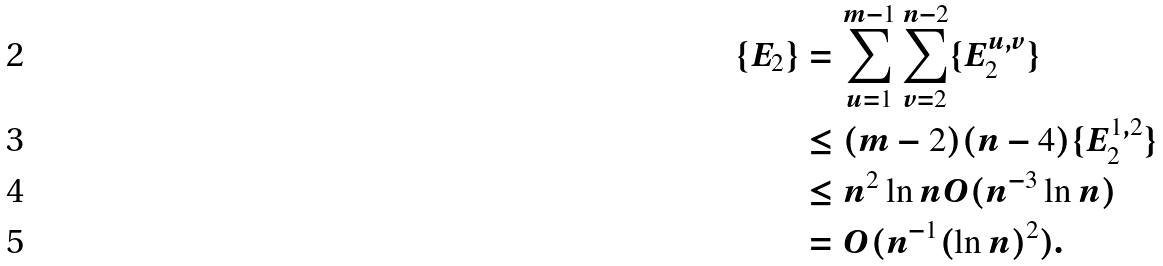Convert formula to latex. <formula><loc_0><loc_0><loc_500><loc_500>\{ E _ { 2 } \} & = \sum _ { u = 1 } ^ { m - 1 } \sum _ { v = 2 } ^ { n - 2 } \{ E _ { 2 } ^ { u , v } \} \\ & \leq ( m - 2 ) ( n - 4 ) \{ E _ { 2 } ^ { 1 , 2 } \} \\ & \leq n ^ { 2 } \ln n O ( n ^ { - 3 } \ln n ) \\ & = O ( n ^ { - 1 } ( \ln n ) ^ { 2 } ) .</formula> 